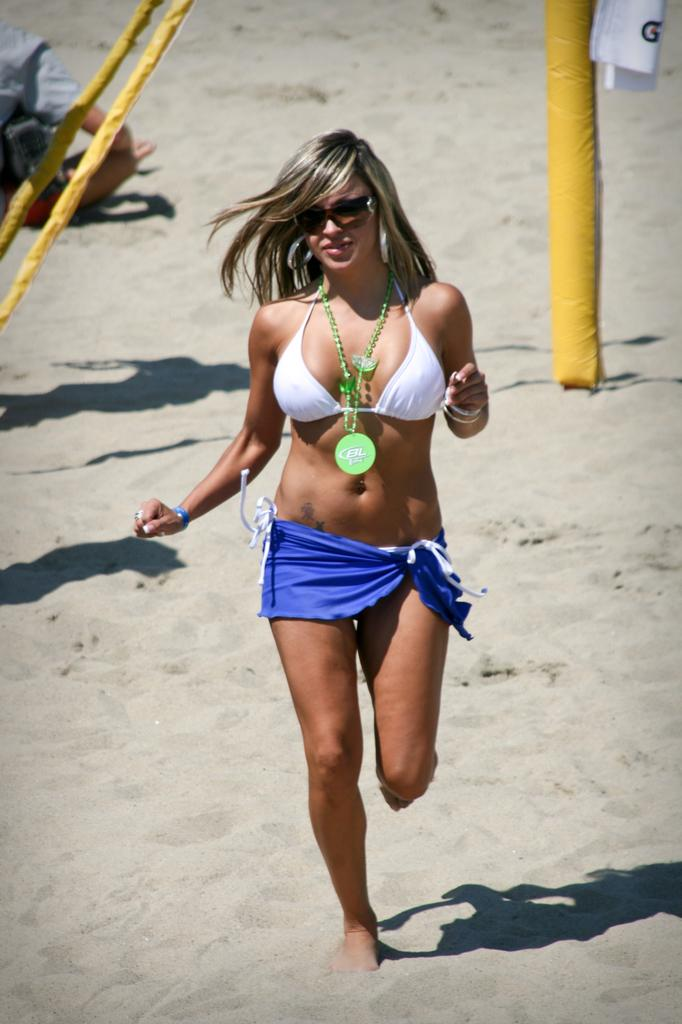What is the woman in the image doing? The woman is running in the image. What type of surface is the woman running on? The woman is running on sand. What color are the objects visible in the image? The objects visible in the image are yellow. Can you describe the other person in the image? There is a person sitting in the image. How many boys are playing with the scarecrow in the image? There are no boys or scarecrow present in the image. 